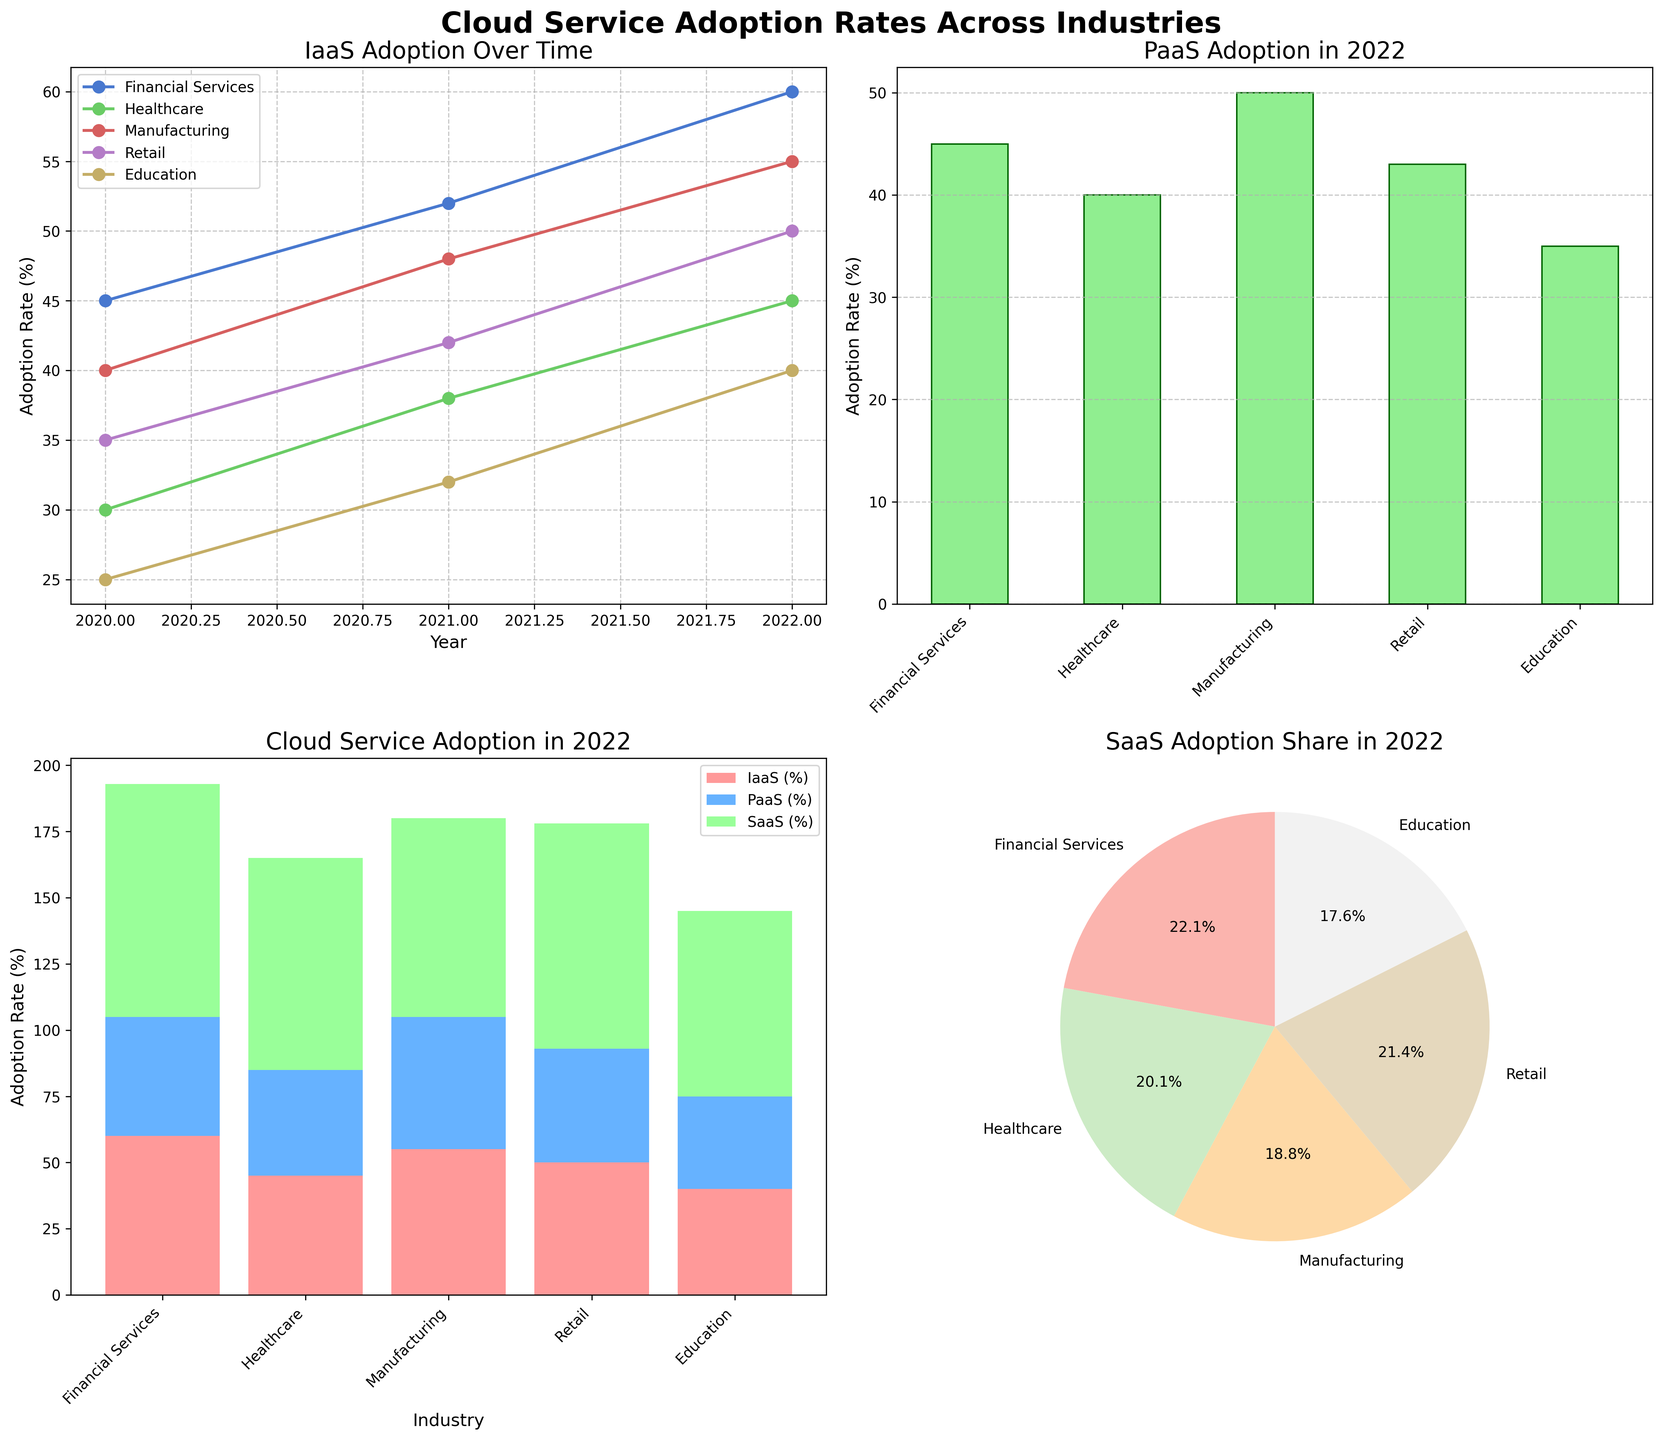Which industry has the highest IaaS adoption rate in 2022? From the line plot in the top left subplot, find the point that represents the highest IaaS adoption rate in 2022 and identify the corresponding industry. The Financial Services industry has the highest IaaS adoption rate in 2022, which is close to 60%.
Answer: Financial Services What is the combined adoption rate of all cloud services for the Healthcare industry in 2022? The stacked bar plot in the bottom left subplot shows the combined adoption rate of all cloud services for each industry in 2022. For Healthcare, sum the heights of the IaaS, PaaS, and SaaS bars. These values are approximately 45% (IaaS), 40% (PaaS), and 80% (SaaS), summing to about 165%.
Answer: 165% How has the adoption rate of PaaS changed for the Retail industry from 2020 to 2022? Look at the values in the line plot for the PaaS adoption rate of the Retail industry over the years. Retail PaaS values are approximately 28% in 2020, 35% in 2021, and 43% in 2022, indicating a steady increase.
Answer: It has increased Which industry had the lowest SaaS adoption rate in 2020? The line plot for SaaS adoption over time in the bottom right subplot can be referred to identify which industry had the lowest SaaS rate in 2020. Education had the lowest rate of about 55%.
Answer: Education Compare the PaaS adoption rates across industries in 2022. Which industry is leading, and which is lagging behind? From the bar plot in the top right subplot depicting PaaS adoption rates across industries in 2022, identify the industries with the highest and lowest values. Financial Services leads with approximately 45%, while Education is lagging with around 35%.
Answer: Leading: Financial Services; Lagging: Education 